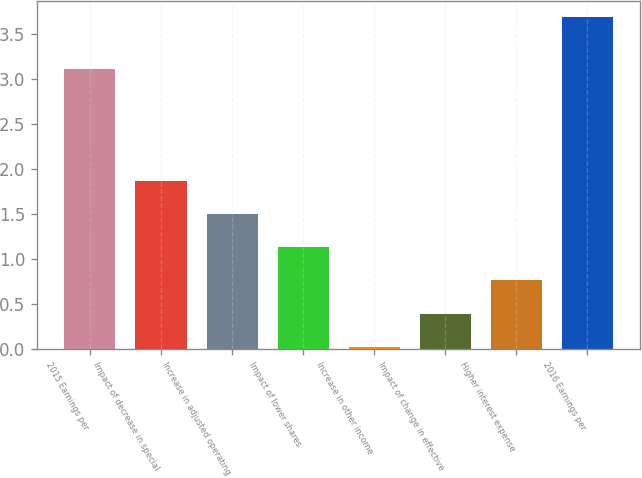Convert chart to OTSL. <chart><loc_0><loc_0><loc_500><loc_500><bar_chart><fcel>2015 Earnings per<fcel>Impact of decrease in special<fcel>Increase in adjusted operating<fcel>Impact of lower shares<fcel>Increase in other income<fcel>Impact of change in effective<fcel>Higher interest expense<fcel>2016 Earnings per<nl><fcel>3.11<fcel>1.87<fcel>1.5<fcel>1.13<fcel>0.02<fcel>0.39<fcel>0.76<fcel>3.69<nl></chart> 